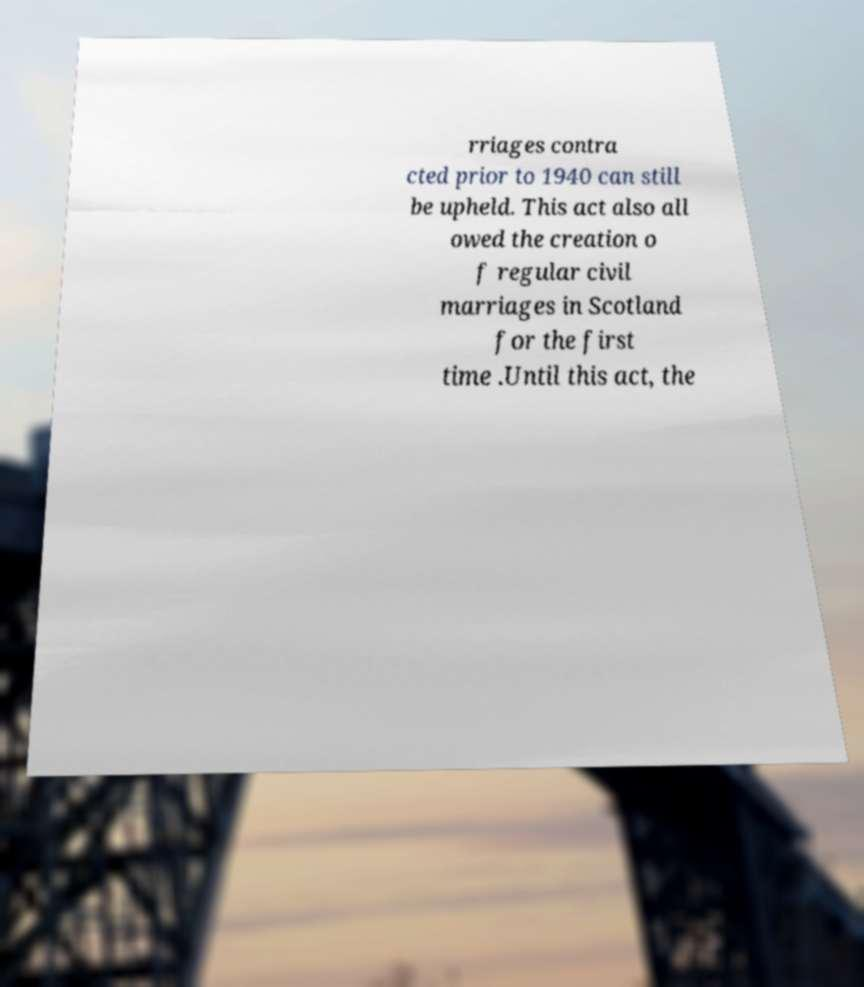Please identify and transcribe the text found in this image. rriages contra cted prior to 1940 can still be upheld. This act also all owed the creation o f regular civil marriages in Scotland for the first time .Until this act, the 